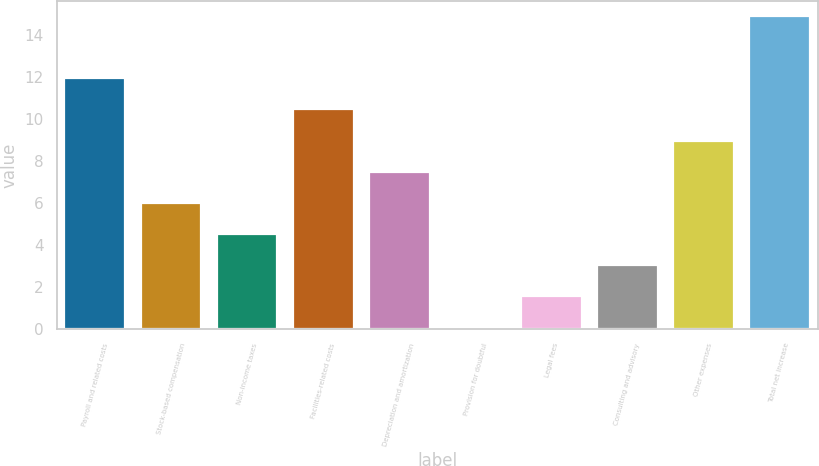<chart> <loc_0><loc_0><loc_500><loc_500><bar_chart><fcel>Payroll and related costs<fcel>Stock-based compensation<fcel>Non-income taxes<fcel>Facilities-related costs<fcel>Depreciation and amortization<fcel>Provision for doubtful<fcel>Legal fees<fcel>Consulting and advisory<fcel>Other expenses<fcel>Total net increase<nl><fcel>11.94<fcel>6.02<fcel>4.54<fcel>10.46<fcel>7.5<fcel>0.1<fcel>1.58<fcel>3.06<fcel>8.98<fcel>14.9<nl></chart> 